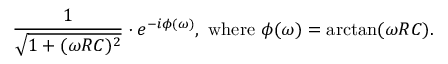<formula> <loc_0><loc_0><loc_500><loc_500>{ \frac { 1 } { \sqrt { 1 + ( \omega R C ) ^ { 2 } } } } \cdot e ^ { - i \phi ( \omega ) } , { w h e r e } \phi ( \omega ) = \arctan ( \omega R C ) .</formula> 